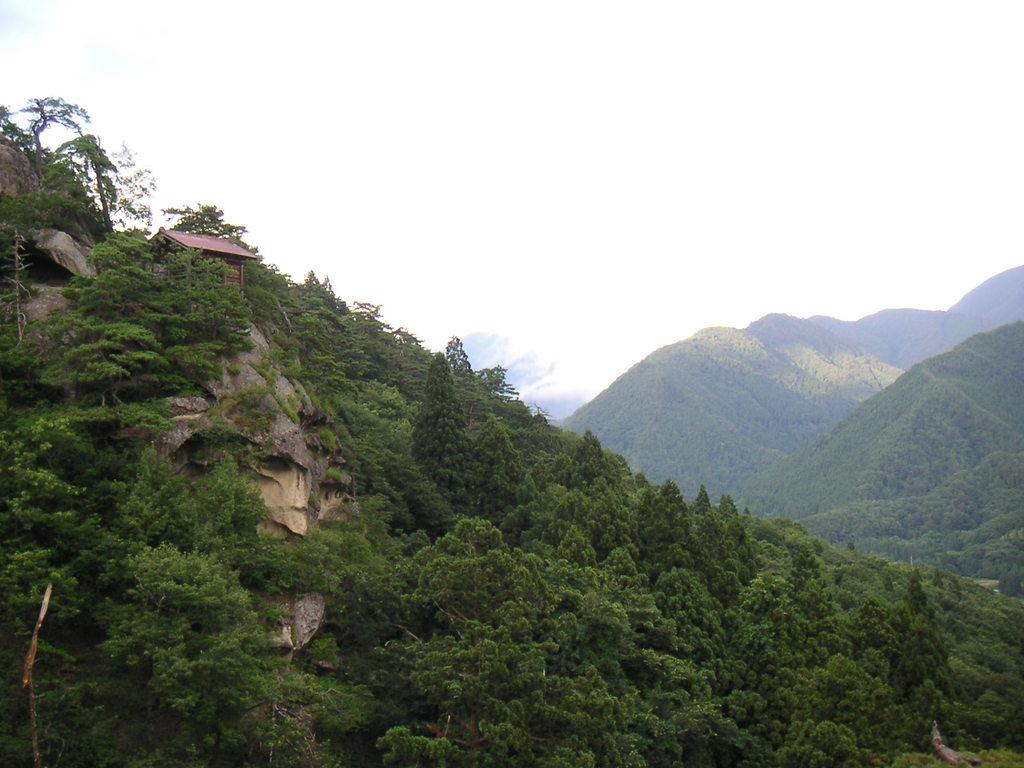What type of vegetation can be seen in the image? There are trees in the image. What geographical feature is visible in the background? There are mountains in the image. What part of the natural environment is visible in the image? The sky is visible in the image. What type of wood can be seen on the chin of the person in the image? There is no person present in the image, and therefore no chin or wood can be observed. What is located in the middle of the image? The provided facts do not specify any particular object or subject being in the middle of the image. 